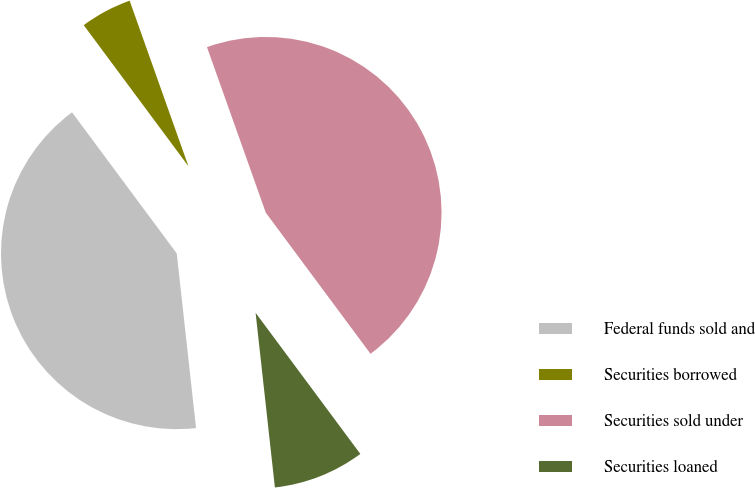<chart> <loc_0><loc_0><loc_500><loc_500><pie_chart><fcel>Federal funds sold and<fcel>Securities borrowed<fcel>Securities sold under<fcel>Securities loaned<nl><fcel>41.59%<fcel>4.73%<fcel>45.27%<fcel>8.41%<nl></chart> 